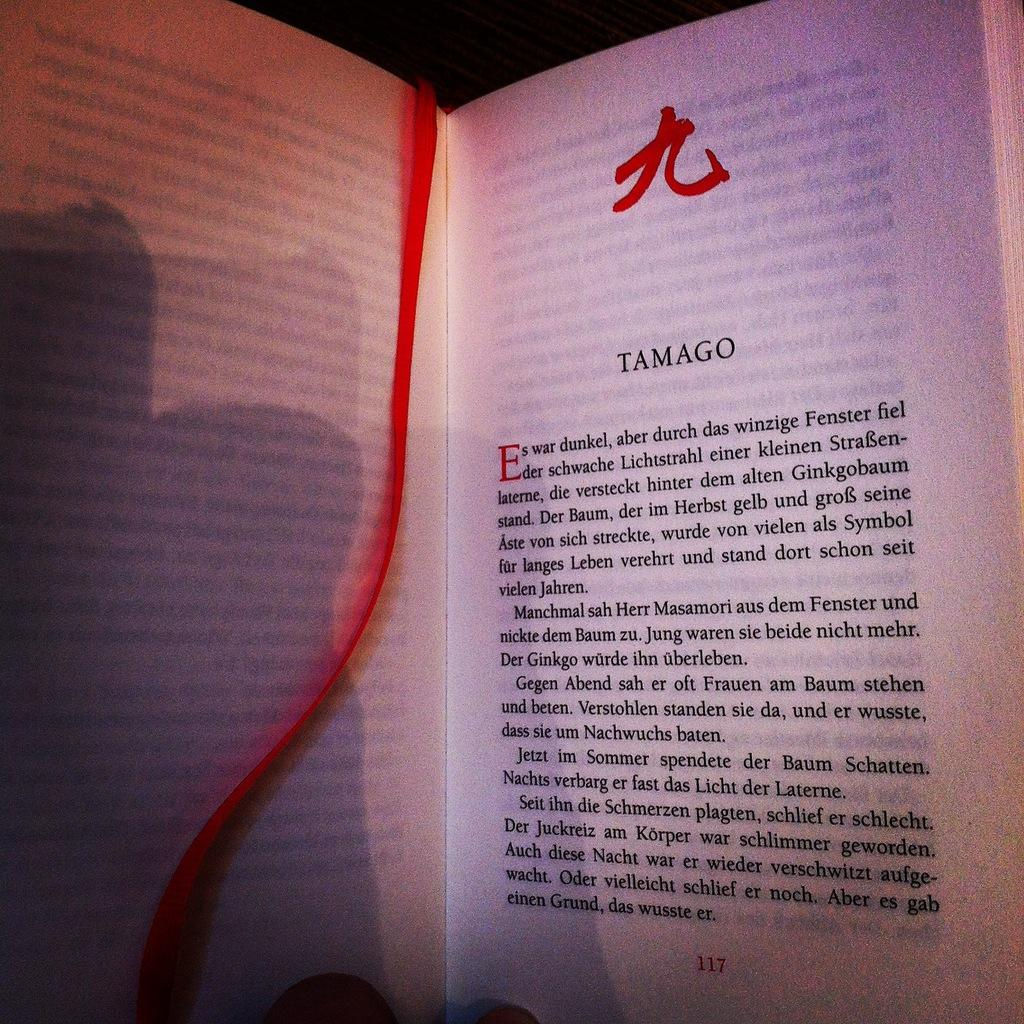<image>
Write a terse but informative summary of the picture. A textbook open to a page titled Tamago. 